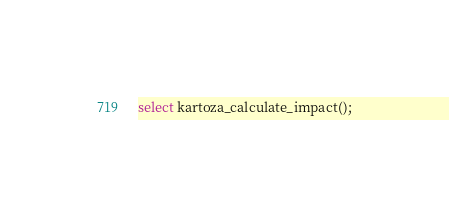<code> <loc_0><loc_0><loc_500><loc_500><_SQL_>select kartoza_calculate_impact();
</code> 